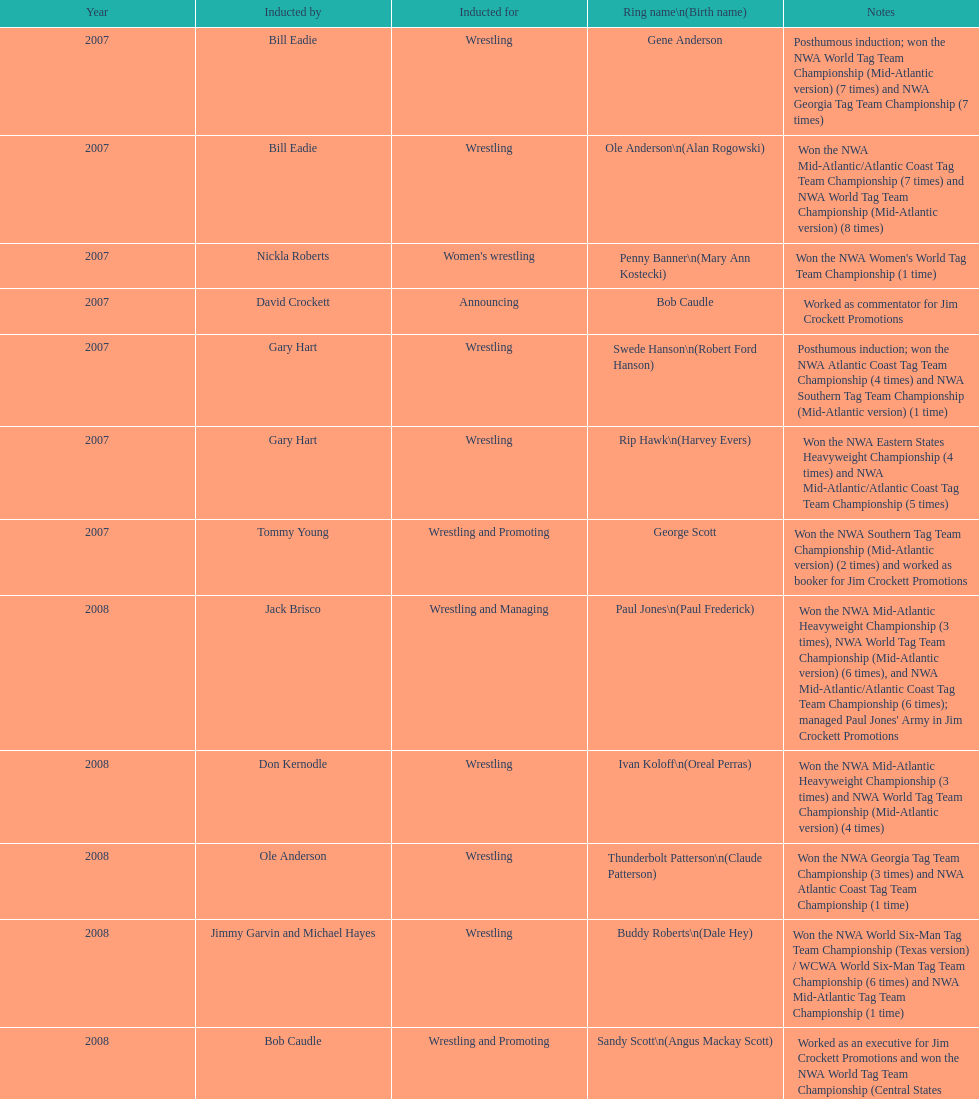Bob caudle was an announcer, who was the other one? Lance Russell. 